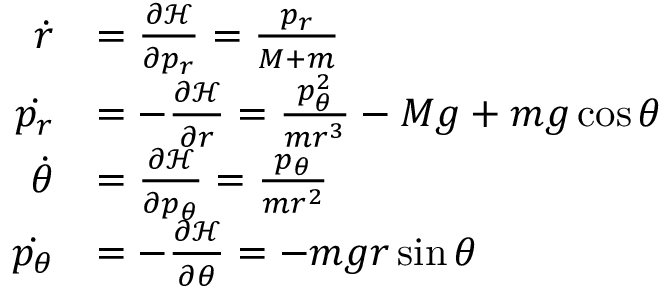Convert formula to latex. <formula><loc_0><loc_0><loc_500><loc_500>{ \begin{array} { r l } { { \dot { r } } } & { = { \frac { \partial { \mathcal { H } } } { \partial { p _ { r } } } } = { \frac { p _ { r } } { M + m } } } \\ { { \dot { p _ { r } } } } & { = - { \frac { \partial { \mathcal { H } } } { \partial { r } } } = { \frac { p _ { \theta } ^ { 2 } } { m r ^ { 3 } } } - M g + m g \cos { \theta } } \\ { { \dot { \theta } } } & { = { \frac { \partial { \mathcal { H } } } { \partial { p _ { \theta } } } } = { \frac { p _ { \theta } } { m r ^ { 2 } } } } \\ { { \dot { p _ { \theta } } } } & { = - { \frac { \partial { \mathcal { H } } } { \partial { \theta } } } = - m g r \sin { \theta } } \end{array} }</formula> 